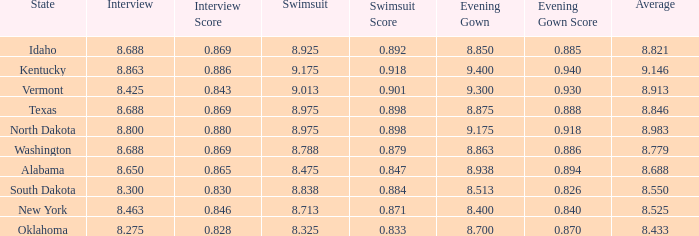I'm looking to parse the entire table for insights. Could you assist me with that? {'header': ['State', 'Interview', 'Interview Score', 'Swimsuit', 'Swimsuit Score', 'Evening Gown', 'Evening Gown Score', 'Average'], 'rows': [['Idaho', '8.688', '0.869', '8.925', '0.892', '8.850', '0.885', '8.821'], ['Kentucky', '8.863', '0.886', '9.175', '0.918', '9.400', '0.940', '9.146'], ['Vermont', '8.425', '0.843', '9.013', '0.901', '9.300', '0.930', '8.913'], ['Texas', '8.688', '0.869', '8.975', '0.898', '8.875', '0.888', '8.846'], ['North Dakota', '8.800', '0.880', '8.975', '0.898', '9.175', '0.918', '8.983'], ['Washington', '8.688', '0.869', '8.788', '0.879', '8.863', '0.886', '8.779'], ['Alabama', '8.650', '0.865', '8.475', '0.847', '8.938', '0.894', '8.688'], ['South Dakota', '8.300', '0.830', '8.838', '0.884', '8.513', '0.826', '8.550'], ['New York', '8.463', '0.846', '8.713', '0.871', '8.400', '0.840', '8.525'], ['Oklahoma', '8.275', '0.828', '8.325', '0.833', '8.700', '0.870', '8.433']]} What is the highest swimsuit score of the contestant with an evening gown larger than 9.175 and an interview score less than 8.425? None. 